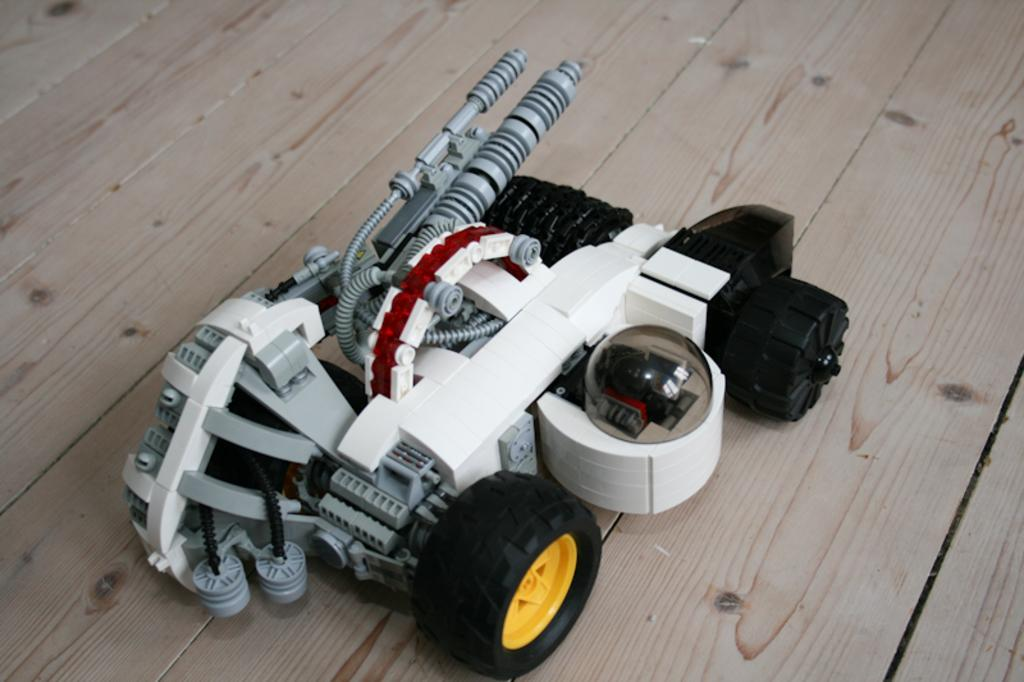What type of object is the main subject in the image? There is a toy vehicle in the image. What is the toy vehicle placed on? The toy vehicle is on a wooden surface. Where is the wooden surface located in the image? The wooden surface is at the bottom of the image. How many birds are flying in a flock above the toy vehicle in the image? There are no birds or flocks present in the image; it only features a toy vehicle on a wooden surface. 